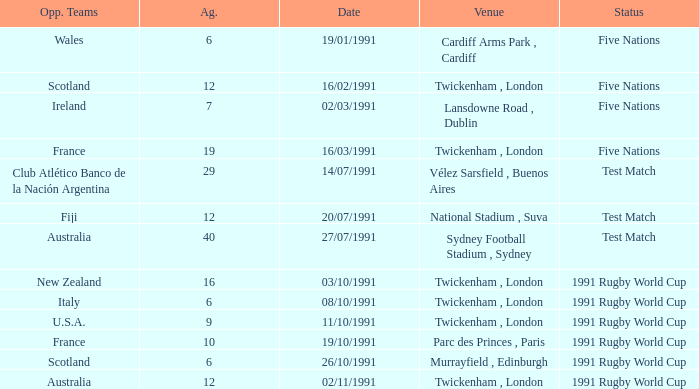What is Venue, when Status is "Test Match", and when Against is "12"? National Stadium , Suva. 